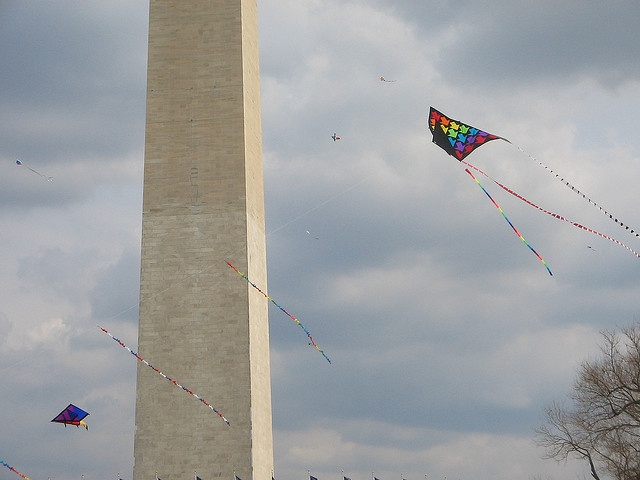Describe the objects in this image and their specific colors. I can see kite in gray, black, lightgray, darkgray, and maroon tones, kite in gray and darkgray tones, kite in gray, black, purple, navy, and darkgray tones, kite in gray, darkgray, brown, and blue tones, and kite in gray, darkgray, and lightgray tones in this image. 